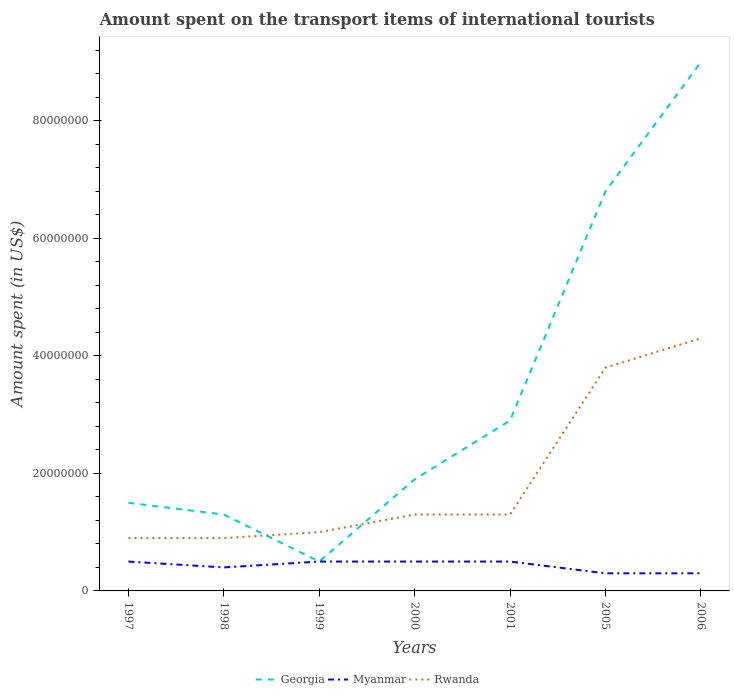How many different coloured lines are there?
Keep it short and to the point. 3. Does the line corresponding to Myanmar intersect with the line corresponding to Rwanda?
Your response must be concise. No. Across all years, what is the maximum amount spent on the transport items of international tourists in Myanmar?
Provide a short and direct response. 3.00e+06. In which year was the amount spent on the transport items of international tourists in Myanmar maximum?
Give a very brief answer. 2005. What is the difference between the highest and the second highest amount spent on the transport items of international tourists in Myanmar?
Make the answer very short. 2.00e+06. What is the difference between the highest and the lowest amount spent on the transport items of international tourists in Myanmar?
Your answer should be compact. 4. Is the amount spent on the transport items of international tourists in Myanmar strictly greater than the amount spent on the transport items of international tourists in Rwanda over the years?
Give a very brief answer. Yes. How many years are there in the graph?
Your response must be concise. 7. Are the values on the major ticks of Y-axis written in scientific E-notation?
Give a very brief answer. No. Does the graph contain grids?
Your answer should be compact. No. Where does the legend appear in the graph?
Provide a succinct answer. Bottom center. How many legend labels are there?
Give a very brief answer. 3. How are the legend labels stacked?
Ensure brevity in your answer.  Horizontal. What is the title of the graph?
Provide a succinct answer. Amount spent on the transport items of international tourists. Does "North America" appear as one of the legend labels in the graph?
Your response must be concise. No. What is the label or title of the X-axis?
Provide a succinct answer. Years. What is the label or title of the Y-axis?
Provide a succinct answer. Amount spent (in US$). What is the Amount spent (in US$) of Georgia in 1997?
Make the answer very short. 1.50e+07. What is the Amount spent (in US$) in Myanmar in 1997?
Make the answer very short. 5.00e+06. What is the Amount spent (in US$) of Rwanda in 1997?
Offer a terse response. 9.00e+06. What is the Amount spent (in US$) of Georgia in 1998?
Your answer should be compact. 1.30e+07. What is the Amount spent (in US$) in Rwanda in 1998?
Your answer should be compact. 9.00e+06. What is the Amount spent (in US$) in Rwanda in 1999?
Your response must be concise. 1.00e+07. What is the Amount spent (in US$) in Georgia in 2000?
Keep it short and to the point. 1.90e+07. What is the Amount spent (in US$) of Myanmar in 2000?
Your answer should be compact. 5.00e+06. What is the Amount spent (in US$) in Rwanda in 2000?
Provide a short and direct response. 1.30e+07. What is the Amount spent (in US$) in Georgia in 2001?
Make the answer very short. 2.90e+07. What is the Amount spent (in US$) in Rwanda in 2001?
Provide a succinct answer. 1.30e+07. What is the Amount spent (in US$) of Georgia in 2005?
Your answer should be very brief. 6.80e+07. What is the Amount spent (in US$) in Myanmar in 2005?
Keep it short and to the point. 3.00e+06. What is the Amount spent (in US$) of Rwanda in 2005?
Keep it short and to the point. 3.80e+07. What is the Amount spent (in US$) of Georgia in 2006?
Give a very brief answer. 9.00e+07. What is the Amount spent (in US$) of Rwanda in 2006?
Provide a succinct answer. 4.30e+07. Across all years, what is the maximum Amount spent (in US$) in Georgia?
Offer a very short reply. 9.00e+07. Across all years, what is the maximum Amount spent (in US$) in Rwanda?
Your response must be concise. 4.30e+07. Across all years, what is the minimum Amount spent (in US$) of Myanmar?
Give a very brief answer. 3.00e+06. Across all years, what is the minimum Amount spent (in US$) in Rwanda?
Make the answer very short. 9.00e+06. What is the total Amount spent (in US$) of Georgia in the graph?
Your answer should be very brief. 2.39e+08. What is the total Amount spent (in US$) in Myanmar in the graph?
Offer a very short reply. 3.00e+07. What is the total Amount spent (in US$) in Rwanda in the graph?
Your response must be concise. 1.35e+08. What is the difference between the Amount spent (in US$) of Rwanda in 1997 and that in 1998?
Provide a short and direct response. 0. What is the difference between the Amount spent (in US$) in Georgia in 1997 and that in 1999?
Keep it short and to the point. 1.00e+07. What is the difference between the Amount spent (in US$) of Myanmar in 1997 and that in 1999?
Your answer should be compact. 0. What is the difference between the Amount spent (in US$) in Rwanda in 1997 and that in 2000?
Make the answer very short. -4.00e+06. What is the difference between the Amount spent (in US$) of Georgia in 1997 and that in 2001?
Provide a succinct answer. -1.40e+07. What is the difference between the Amount spent (in US$) of Myanmar in 1997 and that in 2001?
Provide a succinct answer. 0. What is the difference between the Amount spent (in US$) in Georgia in 1997 and that in 2005?
Ensure brevity in your answer.  -5.30e+07. What is the difference between the Amount spent (in US$) in Myanmar in 1997 and that in 2005?
Offer a very short reply. 2.00e+06. What is the difference between the Amount spent (in US$) in Rwanda in 1997 and that in 2005?
Offer a terse response. -2.90e+07. What is the difference between the Amount spent (in US$) in Georgia in 1997 and that in 2006?
Make the answer very short. -7.50e+07. What is the difference between the Amount spent (in US$) of Myanmar in 1997 and that in 2006?
Make the answer very short. 2.00e+06. What is the difference between the Amount spent (in US$) of Rwanda in 1997 and that in 2006?
Offer a terse response. -3.40e+07. What is the difference between the Amount spent (in US$) of Georgia in 1998 and that in 1999?
Your answer should be very brief. 8.00e+06. What is the difference between the Amount spent (in US$) of Georgia in 1998 and that in 2000?
Keep it short and to the point. -6.00e+06. What is the difference between the Amount spent (in US$) of Georgia in 1998 and that in 2001?
Give a very brief answer. -1.60e+07. What is the difference between the Amount spent (in US$) of Myanmar in 1998 and that in 2001?
Offer a terse response. -1.00e+06. What is the difference between the Amount spent (in US$) of Rwanda in 1998 and that in 2001?
Your answer should be compact. -4.00e+06. What is the difference between the Amount spent (in US$) in Georgia in 1998 and that in 2005?
Ensure brevity in your answer.  -5.50e+07. What is the difference between the Amount spent (in US$) in Rwanda in 1998 and that in 2005?
Keep it short and to the point. -2.90e+07. What is the difference between the Amount spent (in US$) of Georgia in 1998 and that in 2006?
Provide a succinct answer. -7.70e+07. What is the difference between the Amount spent (in US$) in Rwanda in 1998 and that in 2006?
Your answer should be very brief. -3.40e+07. What is the difference between the Amount spent (in US$) of Georgia in 1999 and that in 2000?
Your response must be concise. -1.40e+07. What is the difference between the Amount spent (in US$) in Rwanda in 1999 and that in 2000?
Ensure brevity in your answer.  -3.00e+06. What is the difference between the Amount spent (in US$) of Georgia in 1999 and that in 2001?
Make the answer very short. -2.40e+07. What is the difference between the Amount spent (in US$) of Rwanda in 1999 and that in 2001?
Offer a terse response. -3.00e+06. What is the difference between the Amount spent (in US$) in Georgia in 1999 and that in 2005?
Provide a short and direct response. -6.30e+07. What is the difference between the Amount spent (in US$) of Myanmar in 1999 and that in 2005?
Offer a terse response. 2.00e+06. What is the difference between the Amount spent (in US$) of Rwanda in 1999 and that in 2005?
Make the answer very short. -2.80e+07. What is the difference between the Amount spent (in US$) of Georgia in 1999 and that in 2006?
Your answer should be very brief. -8.50e+07. What is the difference between the Amount spent (in US$) in Rwanda in 1999 and that in 2006?
Offer a terse response. -3.30e+07. What is the difference between the Amount spent (in US$) in Georgia in 2000 and that in 2001?
Your answer should be very brief. -1.00e+07. What is the difference between the Amount spent (in US$) of Myanmar in 2000 and that in 2001?
Give a very brief answer. 0. What is the difference between the Amount spent (in US$) in Rwanda in 2000 and that in 2001?
Offer a terse response. 0. What is the difference between the Amount spent (in US$) of Georgia in 2000 and that in 2005?
Your answer should be very brief. -4.90e+07. What is the difference between the Amount spent (in US$) in Myanmar in 2000 and that in 2005?
Your answer should be compact. 2.00e+06. What is the difference between the Amount spent (in US$) in Rwanda in 2000 and that in 2005?
Offer a terse response. -2.50e+07. What is the difference between the Amount spent (in US$) of Georgia in 2000 and that in 2006?
Keep it short and to the point. -7.10e+07. What is the difference between the Amount spent (in US$) in Myanmar in 2000 and that in 2006?
Offer a very short reply. 2.00e+06. What is the difference between the Amount spent (in US$) in Rwanda in 2000 and that in 2006?
Ensure brevity in your answer.  -3.00e+07. What is the difference between the Amount spent (in US$) of Georgia in 2001 and that in 2005?
Provide a short and direct response. -3.90e+07. What is the difference between the Amount spent (in US$) in Myanmar in 2001 and that in 2005?
Make the answer very short. 2.00e+06. What is the difference between the Amount spent (in US$) of Rwanda in 2001 and that in 2005?
Offer a very short reply. -2.50e+07. What is the difference between the Amount spent (in US$) in Georgia in 2001 and that in 2006?
Make the answer very short. -6.10e+07. What is the difference between the Amount spent (in US$) in Myanmar in 2001 and that in 2006?
Your answer should be very brief. 2.00e+06. What is the difference between the Amount spent (in US$) of Rwanda in 2001 and that in 2006?
Your response must be concise. -3.00e+07. What is the difference between the Amount spent (in US$) in Georgia in 2005 and that in 2006?
Keep it short and to the point. -2.20e+07. What is the difference between the Amount spent (in US$) of Rwanda in 2005 and that in 2006?
Make the answer very short. -5.00e+06. What is the difference between the Amount spent (in US$) of Georgia in 1997 and the Amount spent (in US$) of Myanmar in 1998?
Your answer should be very brief. 1.10e+07. What is the difference between the Amount spent (in US$) of Georgia in 1997 and the Amount spent (in US$) of Myanmar in 1999?
Keep it short and to the point. 1.00e+07. What is the difference between the Amount spent (in US$) of Myanmar in 1997 and the Amount spent (in US$) of Rwanda in 1999?
Your answer should be compact. -5.00e+06. What is the difference between the Amount spent (in US$) in Myanmar in 1997 and the Amount spent (in US$) in Rwanda in 2000?
Your response must be concise. -8.00e+06. What is the difference between the Amount spent (in US$) in Georgia in 1997 and the Amount spent (in US$) in Rwanda in 2001?
Make the answer very short. 2.00e+06. What is the difference between the Amount spent (in US$) of Myanmar in 1997 and the Amount spent (in US$) of Rwanda in 2001?
Your answer should be compact. -8.00e+06. What is the difference between the Amount spent (in US$) of Georgia in 1997 and the Amount spent (in US$) of Rwanda in 2005?
Keep it short and to the point. -2.30e+07. What is the difference between the Amount spent (in US$) of Myanmar in 1997 and the Amount spent (in US$) of Rwanda in 2005?
Provide a short and direct response. -3.30e+07. What is the difference between the Amount spent (in US$) in Georgia in 1997 and the Amount spent (in US$) in Myanmar in 2006?
Offer a very short reply. 1.20e+07. What is the difference between the Amount spent (in US$) of Georgia in 1997 and the Amount spent (in US$) of Rwanda in 2006?
Your answer should be very brief. -2.80e+07. What is the difference between the Amount spent (in US$) in Myanmar in 1997 and the Amount spent (in US$) in Rwanda in 2006?
Make the answer very short. -3.80e+07. What is the difference between the Amount spent (in US$) of Myanmar in 1998 and the Amount spent (in US$) of Rwanda in 1999?
Offer a terse response. -6.00e+06. What is the difference between the Amount spent (in US$) of Georgia in 1998 and the Amount spent (in US$) of Myanmar in 2000?
Give a very brief answer. 8.00e+06. What is the difference between the Amount spent (in US$) in Georgia in 1998 and the Amount spent (in US$) in Rwanda in 2000?
Your answer should be very brief. 0. What is the difference between the Amount spent (in US$) in Myanmar in 1998 and the Amount spent (in US$) in Rwanda in 2000?
Make the answer very short. -9.00e+06. What is the difference between the Amount spent (in US$) of Georgia in 1998 and the Amount spent (in US$) of Rwanda in 2001?
Offer a very short reply. 0. What is the difference between the Amount spent (in US$) in Myanmar in 1998 and the Amount spent (in US$) in Rwanda in 2001?
Offer a terse response. -9.00e+06. What is the difference between the Amount spent (in US$) in Georgia in 1998 and the Amount spent (in US$) in Myanmar in 2005?
Provide a succinct answer. 1.00e+07. What is the difference between the Amount spent (in US$) in Georgia in 1998 and the Amount spent (in US$) in Rwanda in 2005?
Give a very brief answer. -2.50e+07. What is the difference between the Amount spent (in US$) of Myanmar in 1998 and the Amount spent (in US$) of Rwanda in 2005?
Provide a succinct answer. -3.40e+07. What is the difference between the Amount spent (in US$) of Georgia in 1998 and the Amount spent (in US$) of Myanmar in 2006?
Your answer should be very brief. 1.00e+07. What is the difference between the Amount spent (in US$) of Georgia in 1998 and the Amount spent (in US$) of Rwanda in 2006?
Your answer should be compact. -3.00e+07. What is the difference between the Amount spent (in US$) in Myanmar in 1998 and the Amount spent (in US$) in Rwanda in 2006?
Give a very brief answer. -3.90e+07. What is the difference between the Amount spent (in US$) of Georgia in 1999 and the Amount spent (in US$) of Rwanda in 2000?
Offer a very short reply. -8.00e+06. What is the difference between the Amount spent (in US$) in Myanmar in 1999 and the Amount spent (in US$) in Rwanda in 2000?
Make the answer very short. -8.00e+06. What is the difference between the Amount spent (in US$) in Georgia in 1999 and the Amount spent (in US$) in Myanmar in 2001?
Your answer should be compact. 0. What is the difference between the Amount spent (in US$) of Georgia in 1999 and the Amount spent (in US$) of Rwanda in 2001?
Your answer should be very brief. -8.00e+06. What is the difference between the Amount spent (in US$) in Myanmar in 1999 and the Amount spent (in US$) in Rwanda in 2001?
Make the answer very short. -8.00e+06. What is the difference between the Amount spent (in US$) of Georgia in 1999 and the Amount spent (in US$) of Myanmar in 2005?
Keep it short and to the point. 2.00e+06. What is the difference between the Amount spent (in US$) in Georgia in 1999 and the Amount spent (in US$) in Rwanda in 2005?
Offer a very short reply. -3.30e+07. What is the difference between the Amount spent (in US$) in Myanmar in 1999 and the Amount spent (in US$) in Rwanda in 2005?
Make the answer very short. -3.30e+07. What is the difference between the Amount spent (in US$) of Georgia in 1999 and the Amount spent (in US$) of Rwanda in 2006?
Offer a terse response. -3.80e+07. What is the difference between the Amount spent (in US$) in Myanmar in 1999 and the Amount spent (in US$) in Rwanda in 2006?
Offer a very short reply. -3.80e+07. What is the difference between the Amount spent (in US$) in Georgia in 2000 and the Amount spent (in US$) in Myanmar in 2001?
Ensure brevity in your answer.  1.40e+07. What is the difference between the Amount spent (in US$) of Myanmar in 2000 and the Amount spent (in US$) of Rwanda in 2001?
Provide a succinct answer. -8.00e+06. What is the difference between the Amount spent (in US$) of Georgia in 2000 and the Amount spent (in US$) of Myanmar in 2005?
Ensure brevity in your answer.  1.60e+07. What is the difference between the Amount spent (in US$) of Georgia in 2000 and the Amount spent (in US$) of Rwanda in 2005?
Your answer should be very brief. -1.90e+07. What is the difference between the Amount spent (in US$) of Myanmar in 2000 and the Amount spent (in US$) of Rwanda in 2005?
Your answer should be compact. -3.30e+07. What is the difference between the Amount spent (in US$) of Georgia in 2000 and the Amount spent (in US$) of Myanmar in 2006?
Keep it short and to the point. 1.60e+07. What is the difference between the Amount spent (in US$) of Georgia in 2000 and the Amount spent (in US$) of Rwanda in 2006?
Your answer should be very brief. -2.40e+07. What is the difference between the Amount spent (in US$) of Myanmar in 2000 and the Amount spent (in US$) of Rwanda in 2006?
Provide a succinct answer. -3.80e+07. What is the difference between the Amount spent (in US$) in Georgia in 2001 and the Amount spent (in US$) in Myanmar in 2005?
Provide a succinct answer. 2.60e+07. What is the difference between the Amount spent (in US$) of Georgia in 2001 and the Amount spent (in US$) of Rwanda in 2005?
Your answer should be very brief. -9.00e+06. What is the difference between the Amount spent (in US$) in Myanmar in 2001 and the Amount spent (in US$) in Rwanda in 2005?
Offer a very short reply. -3.30e+07. What is the difference between the Amount spent (in US$) in Georgia in 2001 and the Amount spent (in US$) in Myanmar in 2006?
Offer a terse response. 2.60e+07. What is the difference between the Amount spent (in US$) in Georgia in 2001 and the Amount spent (in US$) in Rwanda in 2006?
Keep it short and to the point. -1.40e+07. What is the difference between the Amount spent (in US$) in Myanmar in 2001 and the Amount spent (in US$) in Rwanda in 2006?
Your response must be concise. -3.80e+07. What is the difference between the Amount spent (in US$) in Georgia in 2005 and the Amount spent (in US$) in Myanmar in 2006?
Offer a very short reply. 6.50e+07. What is the difference between the Amount spent (in US$) in Georgia in 2005 and the Amount spent (in US$) in Rwanda in 2006?
Your response must be concise. 2.50e+07. What is the difference between the Amount spent (in US$) in Myanmar in 2005 and the Amount spent (in US$) in Rwanda in 2006?
Make the answer very short. -4.00e+07. What is the average Amount spent (in US$) of Georgia per year?
Keep it short and to the point. 3.41e+07. What is the average Amount spent (in US$) in Myanmar per year?
Your response must be concise. 4.29e+06. What is the average Amount spent (in US$) of Rwanda per year?
Give a very brief answer. 1.93e+07. In the year 1997, what is the difference between the Amount spent (in US$) in Georgia and Amount spent (in US$) in Rwanda?
Your answer should be compact. 6.00e+06. In the year 1998, what is the difference between the Amount spent (in US$) in Georgia and Amount spent (in US$) in Myanmar?
Provide a short and direct response. 9.00e+06. In the year 1998, what is the difference between the Amount spent (in US$) in Georgia and Amount spent (in US$) in Rwanda?
Make the answer very short. 4.00e+06. In the year 1998, what is the difference between the Amount spent (in US$) in Myanmar and Amount spent (in US$) in Rwanda?
Provide a succinct answer. -5.00e+06. In the year 1999, what is the difference between the Amount spent (in US$) in Georgia and Amount spent (in US$) in Rwanda?
Your answer should be very brief. -5.00e+06. In the year 1999, what is the difference between the Amount spent (in US$) of Myanmar and Amount spent (in US$) of Rwanda?
Ensure brevity in your answer.  -5.00e+06. In the year 2000, what is the difference between the Amount spent (in US$) of Georgia and Amount spent (in US$) of Myanmar?
Give a very brief answer. 1.40e+07. In the year 2000, what is the difference between the Amount spent (in US$) in Myanmar and Amount spent (in US$) in Rwanda?
Your response must be concise. -8.00e+06. In the year 2001, what is the difference between the Amount spent (in US$) of Georgia and Amount spent (in US$) of Myanmar?
Provide a short and direct response. 2.40e+07. In the year 2001, what is the difference between the Amount spent (in US$) in Georgia and Amount spent (in US$) in Rwanda?
Provide a succinct answer. 1.60e+07. In the year 2001, what is the difference between the Amount spent (in US$) in Myanmar and Amount spent (in US$) in Rwanda?
Your response must be concise. -8.00e+06. In the year 2005, what is the difference between the Amount spent (in US$) in Georgia and Amount spent (in US$) in Myanmar?
Your response must be concise. 6.50e+07. In the year 2005, what is the difference between the Amount spent (in US$) of Georgia and Amount spent (in US$) of Rwanda?
Offer a terse response. 3.00e+07. In the year 2005, what is the difference between the Amount spent (in US$) in Myanmar and Amount spent (in US$) in Rwanda?
Ensure brevity in your answer.  -3.50e+07. In the year 2006, what is the difference between the Amount spent (in US$) of Georgia and Amount spent (in US$) of Myanmar?
Make the answer very short. 8.70e+07. In the year 2006, what is the difference between the Amount spent (in US$) of Georgia and Amount spent (in US$) of Rwanda?
Provide a succinct answer. 4.70e+07. In the year 2006, what is the difference between the Amount spent (in US$) of Myanmar and Amount spent (in US$) of Rwanda?
Provide a short and direct response. -4.00e+07. What is the ratio of the Amount spent (in US$) in Georgia in 1997 to that in 1998?
Give a very brief answer. 1.15. What is the ratio of the Amount spent (in US$) of Myanmar in 1997 to that in 1998?
Offer a very short reply. 1.25. What is the ratio of the Amount spent (in US$) of Rwanda in 1997 to that in 1998?
Offer a very short reply. 1. What is the ratio of the Amount spent (in US$) in Myanmar in 1997 to that in 1999?
Make the answer very short. 1. What is the ratio of the Amount spent (in US$) of Georgia in 1997 to that in 2000?
Keep it short and to the point. 0.79. What is the ratio of the Amount spent (in US$) of Myanmar in 1997 to that in 2000?
Your answer should be very brief. 1. What is the ratio of the Amount spent (in US$) of Rwanda in 1997 to that in 2000?
Your answer should be compact. 0.69. What is the ratio of the Amount spent (in US$) of Georgia in 1997 to that in 2001?
Your answer should be compact. 0.52. What is the ratio of the Amount spent (in US$) of Myanmar in 1997 to that in 2001?
Your response must be concise. 1. What is the ratio of the Amount spent (in US$) of Rwanda in 1997 to that in 2001?
Your answer should be very brief. 0.69. What is the ratio of the Amount spent (in US$) in Georgia in 1997 to that in 2005?
Offer a very short reply. 0.22. What is the ratio of the Amount spent (in US$) in Myanmar in 1997 to that in 2005?
Provide a short and direct response. 1.67. What is the ratio of the Amount spent (in US$) of Rwanda in 1997 to that in 2005?
Provide a succinct answer. 0.24. What is the ratio of the Amount spent (in US$) of Myanmar in 1997 to that in 2006?
Give a very brief answer. 1.67. What is the ratio of the Amount spent (in US$) in Rwanda in 1997 to that in 2006?
Provide a succinct answer. 0.21. What is the ratio of the Amount spent (in US$) of Rwanda in 1998 to that in 1999?
Provide a short and direct response. 0.9. What is the ratio of the Amount spent (in US$) of Georgia in 1998 to that in 2000?
Your answer should be compact. 0.68. What is the ratio of the Amount spent (in US$) of Myanmar in 1998 to that in 2000?
Keep it short and to the point. 0.8. What is the ratio of the Amount spent (in US$) in Rwanda in 1998 to that in 2000?
Provide a succinct answer. 0.69. What is the ratio of the Amount spent (in US$) in Georgia in 1998 to that in 2001?
Offer a terse response. 0.45. What is the ratio of the Amount spent (in US$) of Rwanda in 1998 to that in 2001?
Your response must be concise. 0.69. What is the ratio of the Amount spent (in US$) of Georgia in 1998 to that in 2005?
Offer a very short reply. 0.19. What is the ratio of the Amount spent (in US$) in Myanmar in 1998 to that in 2005?
Ensure brevity in your answer.  1.33. What is the ratio of the Amount spent (in US$) in Rwanda in 1998 to that in 2005?
Your response must be concise. 0.24. What is the ratio of the Amount spent (in US$) in Georgia in 1998 to that in 2006?
Ensure brevity in your answer.  0.14. What is the ratio of the Amount spent (in US$) in Rwanda in 1998 to that in 2006?
Your answer should be very brief. 0.21. What is the ratio of the Amount spent (in US$) in Georgia in 1999 to that in 2000?
Your answer should be compact. 0.26. What is the ratio of the Amount spent (in US$) in Myanmar in 1999 to that in 2000?
Provide a short and direct response. 1. What is the ratio of the Amount spent (in US$) in Rwanda in 1999 to that in 2000?
Your answer should be compact. 0.77. What is the ratio of the Amount spent (in US$) in Georgia in 1999 to that in 2001?
Offer a terse response. 0.17. What is the ratio of the Amount spent (in US$) in Myanmar in 1999 to that in 2001?
Offer a terse response. 1. What is the ratio of the Amount spent (in US$) in Rwanda in 1999 to that in 2001?
Your answer should be very brief. 0.77. What is the ratio of the Amount spent (in US$) of Georgia in 1999 to that in 2005?
Ensure brevity in your answer.  0.07. What is the ratio of the Amount spent (in US$) in Myanmar in 1999 to that in 2005?
Give a very brief answer. 1.67. What is the ratio of the Amount spent (in US$) of Rwanda in 1999 to that in 2005?
Your answer should be very brief. 0.26. What is the ratio of the Amount spent (in US$) in Georgia in 1999 to that in 2006?
Make the answer very short. 0.06. What is the ratio of the Amount spent (in US$) of Myanmar in 1999 to that in 2006?
Offer a very short reply. 1.67. What is the ratio of the Amount spent (in US$) in Rwanda in 1999 to that in 2006?
Offer a terse response. 0.23. What is the ratio of the Amount spent (in US$) in Georgia in 2000 to that in 2001?
Your answer should be compact. 0.66. What is the ratio of the Amount spent (in US$) in Myanmar in 2000 to that in 2001?
Your response must be concise. 1. What is the ratio of the Amount spent (in US$) in Rwanda in 2000 to that in 2001?
Provide a succinct answer. 1. What is the ratio of the Amount spent (in US$) of Georgia in 2000 to that in 2005?
Your answer should be compact. 0.28. What is the ratio of the Amount spent (in US$) of Rwanda in 2000 to that in 2005?
Provide a succinct answer. 0.34. What is the ratio of the Amount spent (in US$) in Georgia in 2000 to that in 2006?
Your response must be concise. 0.21. What is the ratio of the Amount spent (in US$) in Myanmar in 2000 to that in 2006?
Your answer should be compact. 1.67. What is the ratio of the Amount spent (in US$) of Rwanda in 2000 to that in 2006?
Provide a succinct answer. 0.3. What is the ratio of the Amount spent (in US$) in Georgia in 2001 to that in 2005?
Provide a short and direct response. 0.43. What is the ratio of the Amount spent (in US$) in Myanmar in 2001 to that in 2005?
Your answer should be very brief. 1.67. What is the ratio of the Amount spent (in US$) of Rwanda in 2001 to that in 2005?
Provide a succinct answer. 0.34. What is the ratio of the Amount spent (in US$) in Georgia in 2001 to that in 2006?
Offer a very short reply. 0.32. What is the ratio of the Amount spent (in US$) of Myanmar in 2001 to that in 2006?
Provide a succinct answer. 1.67. What is the ratio of the Amount spent (in US$) in Rwanda in 2001 to that in 2006?
Give a very brief answer. 0.3. What is the ratio of the Amount spent (in US$) of Georgia in 2005 to that in 2006?
Provide a short and direct response. 0.76. What is the ratio of the Amount spent (in US$) of Myanmar in 2005 to that in 2006?
Keep it short and to the point. 1. What is the ratio of the Amount spent (in US$) in Rwanda in 2005 to that in 2006?
Provide a short and direct response. 0.88. What is the difference between the highest and the second highest Amount spent (in US$) of Georgia?
Your answer should be very brief. 2.20e+07. What is the difference between the highest and the second highest Amount spent (in US$) in Rwanda?
Your response must be concise. 5.00e+06. What is the difference between the highest and the lowest Amount spent (in US$) of Georgia?
Your response must be concise. 8.50e+07. What is the difference between the highest and the lowest Amount spent (in US$) of Rwanda?
Keep it short and to the point. 3.40e+07. 